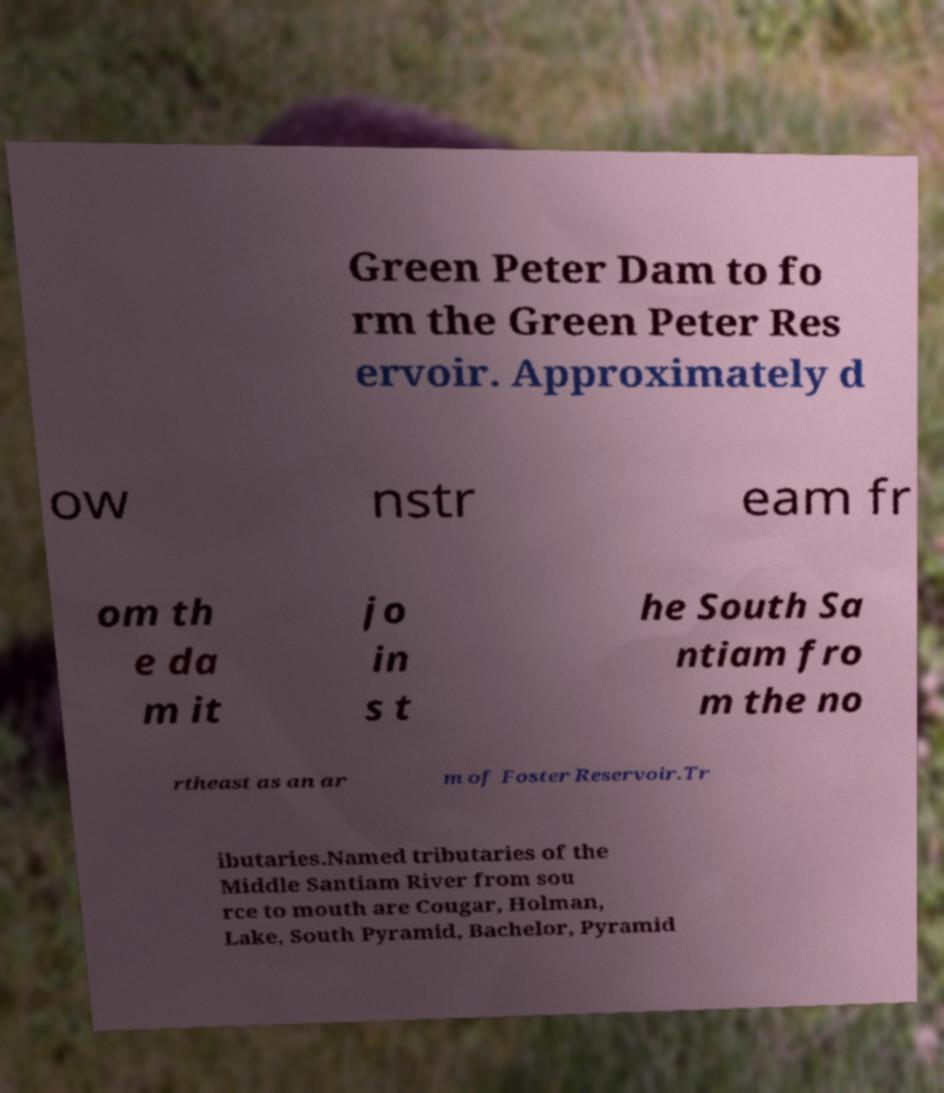Can you accurately transcribe the text from the provided image for me? Green Peter Dam to fo rm the Green Peter Res ervoir. Approximately d ow nstr eam fr om th e da m it jo in s t he South Sa ntiam fro m the no rtheast as an ar m of Foster Reservoir.Tr ibutaries.Named tributaries of the Middle Santiam River from sou rce to mouth are Cougar, Holman, Lake, South Pyramid, Bachelor, Pyramid 